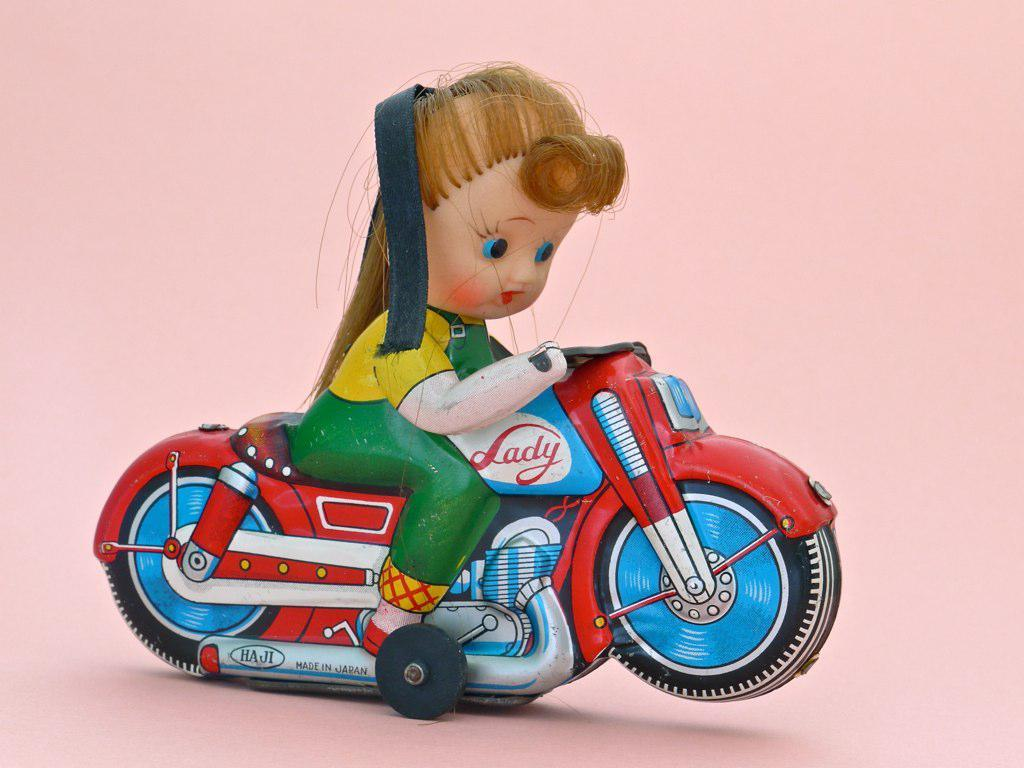What is the main subject of the image? The main subject of the image is a toy of a girl. What is the toy girl doing in the image? The toy girl appears to be riding a toy bike. What color is the background of the image? The background of the image is pink in color. Can you see any deer in the image? No, there are no deer present in the image. Is there a cover on the toy bike in the image? There is no mention of a cover on the toy bike in the image. 